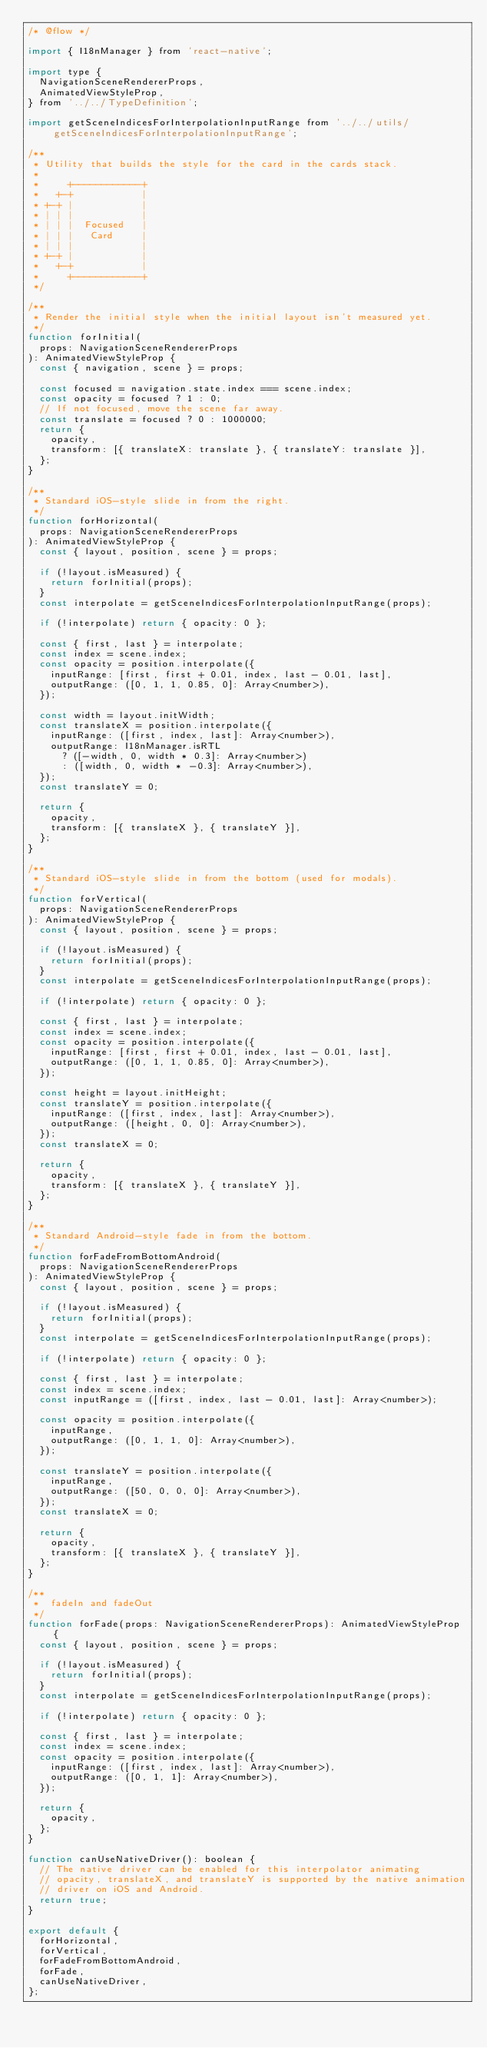Convert code to text. <code><loc_0><loc_0><loc_500><loc_500><_JavaScript_>/* @flow */

import { I18nManager } from 'react-native';

import type {
  NavigationSceneRendererProps,
  AnimatedViewStyleProp,
} from '../../TypeDefinition';

import getSceneIndicesForInterpolationInputRange from '../../utils/getSceneIndicesForInterpolationInputRange';

/**
 * Utility that builds the style for the card in the cards stack.
 *
 *     +------------+
 *   +-+            |
 * +-+ |            |
 * | | |            |
 * | | |  Focused   |
 * | | |   Card     |
 * | | |            |
 * +-+ |            |
 *   +-+            |
 *     +------------+
 */

/**
 * Render the initial style when the initial layout isn't measured yet.
 */
function forInitial(
  props: NavigationSceneRendererProps
): AnimatedViewStyleProp {
  const { navigation, scene } = props;

  const focused = navigation.state.index === scene.index;
  const opacity = focused ? 1 : 0;
  // If not focused, move the scene far away.
  const translate = focused ? 0 : 1000000;
  return {
    opacity,
    transform: [{ translateX: translate }, { translateY: translate }],
  };
}

/**
 * Standard iOS-style slide in from the right.
 */
function forHorizontal(
  props: NavigationSceneRendererProps
): AnimatedViewStyleProp {
  const { layout, position, scene } = props;

  if (!layout.isMeasured) {
    return forInitial(props);
  }
  const interpolate = getSceneIndicesForInterpolationInputRange(props);

  if (!interpolate) return { opacity: 0 };

  const { first, last } = interpolate;
  const index = scene.index;
  const opacity = position.interpolate({
    inputRange: [first, first + 0.01, index, last - 0.01, last],
    outputRange: ([0, 1, 1, 0.85, 0]: Array<number>),
  });

  const width = layout.initWidth;
  const translateX = position.interpolate({
    inputRange: ([first, index, last]: Array<number>),
    outputRange: I18nManager.isRTL
      ? ([-width, 0, width * 0.3]: Array<number>)
      : ([width, 0, width * -0.3]: Array<number>),
  });
  const translateY = 0;

  return {
    opacity,
    transform: [{ translateX }, { translateY }],
  };
}

/**
 * Standard iOS-style slide in from the bottom (used for modals).
 */
function forVertical(
  props: NavigationSceneRendererProps
): AnimatedViewStyleProp {
  const { layout, position, scene } = props;

  if (!layout.isMeasured) {
    return forInitial(props);
  }
  const interpolate = getSceneIndicesForInterpolationInputRange(props);

  if (!interpolate) return { opacity: 0 };

  const { first, last } = interpolate;
  const index = scene.index;
  const opacity = position.interpolate({
    inputRange: [first, first + 0.01, index, last - 0.01, last],
    outputRange: ([0, 1, 1, 0.85, 0]: Array<number>),
  });

  const height = layout.initHeight;
  const translateY = position.interpolate({
    inputRange: ([first, index, last]: Array<number>),
    outputRange: ([height, 0, 0]: Array<number>),
  });
  const translateX = 0;

  return {
    opacity,
    transform: [{ translateX }, { translateY }],
  };
}

/**
 * Standard Android-style fade in from the bottom.
 */
function forFadeFromBottomAndroid(
  props: NavigationSceneRendererProps
): AnimatedViewStyleProp {
  const { layout, position, scene } = props;

  if (!layout.isMeasured) {
    return forInitial(props);
  }
  const interpolate = getSceneIndicesForInterpolationInputRange(props);

  if (!interpolate) return { opacity: 0 };

  const { first, last } = interpolate;
  const index = scene.index;
  const inputRange = ([first, index, last - 0.01, last]: Array<number>);

  const opacity = position.interpolate({
    inputRange,
    outputRange: ([0, 1, 1, 0]: Array<number>),
  });

  const translateY = position.interpolate({
    inputRange,
    outputRange: ([50, 0, 0, 0]: Array<number>),
  });
  const translateX = 0;

  return {
    opacity,
    transform: [{ translateX }, { translateY }],
  };
}

/**
 *  fadeIn and fadeOut
 */
function forFade(props: NavigationSceneRendererProps): AnimatedViewStyleProp {
  const { layout, position, scene } = props;

  if (!layout.isMeasured) {
    return forInitial(props);
  }
  const interpolate = getSceneIndicesForInterpolationInputRange(props);

  if (!interpolate) return { opacity: 0 };

  const { first, last } = interpolate;
  const index = scene.index;
  const opacity = position.interpolate({
    inputRange: ([first, index, last]: Array<number>),
    outputRange: ([0, 1, 1]: Array<number>),
  });

  return {
    opacity,
  };
}

function canUseNativeDriver(): boolean {
  // The native driver can be enabled for this interpolator animating
  // opacity, translateX, and translateY is supported by the native animation
  // driver on iOS and Android.
  return true;
}

export default {
  forHorizontal,
  forVertical,
  forFadeFromBottomAndroid,
  forFade,
  canUseNativeDriver,
};
</code> 